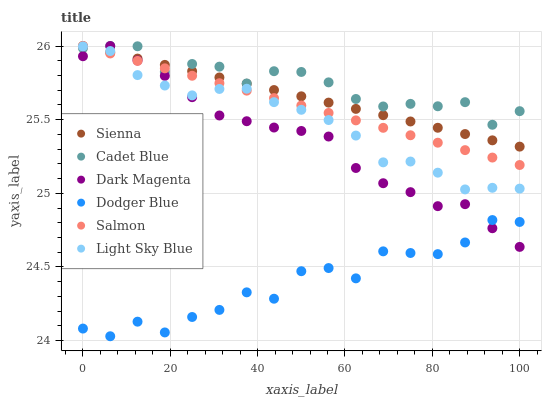Does Dodger Blue have the minimum area under the curve?
Answer yes or no. Yes. Does Cadet Blue have the maximum area under the curve?
Answer yes or no. Yes. Does Dark Magenta have the minimum area under the curve?
Answer yes or no. No. Does Dark Magenta have the maximum area under the curve?
Answer yes or no. No. Is Sienna the smoothest?
Answer yes or no. Yes. Is Dodger Blue the roughest?
Answer yes or no. Yes. Is Dark Magenta the smoothest?
Answer yes or no. No. Is Dark Magenta the roughest?
Answer yes or no. No. Does Dodger Blue have the lowest value?
Answer yes or no. Yes. Does Dark Magenta have the lowest value?
Answer yes or no. No. Does Sienna have the highest value?
Answer yes or no. Yes. Does Light Sky Blue have the highest value?
Answer yes or no. No. Is Dodger Blue less than Light Sky Blue?
Answer yes or no. Yes. Is Cadet Blue greater than Dodger Blue?
Answer yes or no. Yes. Does Light Sky Blue intersect Sienna?
Answer yes or no. Yes. Is Light Sky Blue less than Sienna?
Answer yes or no. No. Is Light Sky Blue greater than Sienna?
Answer yes or no. No. Does Dodger Blue intersect Light Sky Blue?
Answer yes or no. No. 